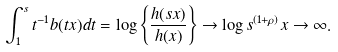<formula> <loc_0><loc_0><loc_500><loc_500>\int _ { 1 } ^ { s } t ^ { - 1 } b ( t x ) d t = \log \left \{ \frac { h ( s x ) } { h ( x ) } \right \} \rightarrow \log s ^ { ( 1 + \rho ) } x \rightarrow \infty .</formula> 